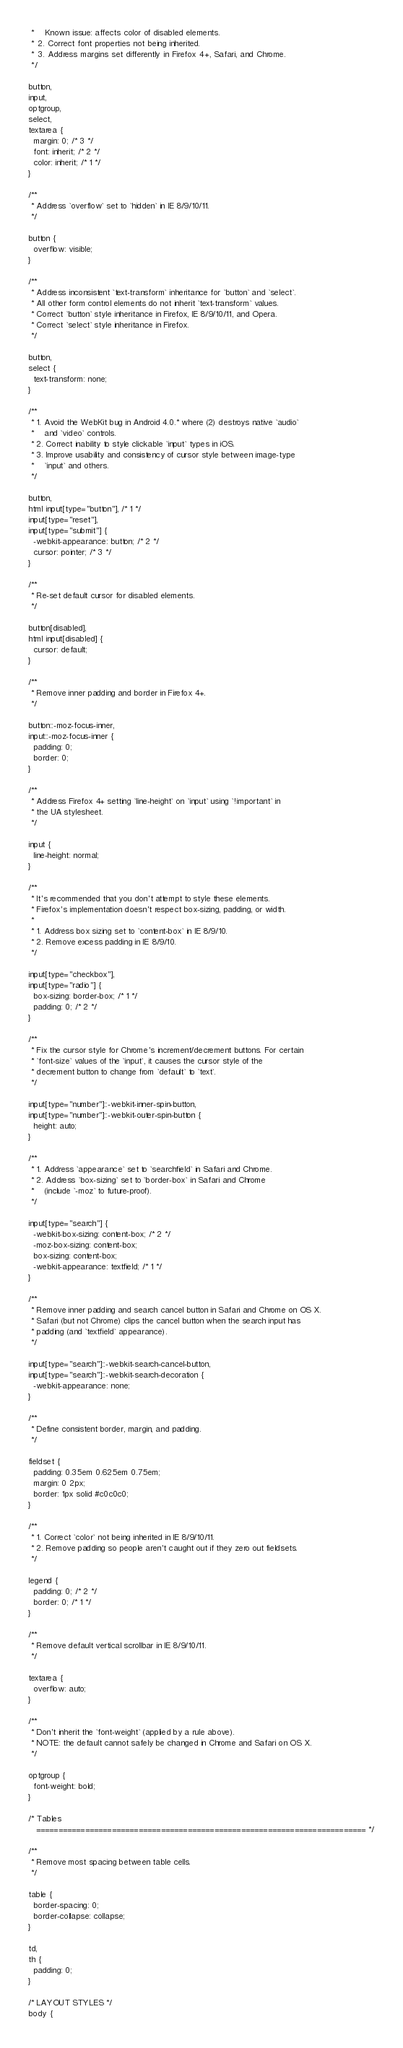Convert code to text. <code><loc_0><loc_0><loc_500><loc_500><_CSS_> *    Known issue: affects color of disabled elements.
 * 2. Correct font properties not being inherited.
 * 3. Address margins set differently in Firefox 4+, Safari, and Chrome.
 */

button,
input,
optgroup,
select,
textarea {
  margin: 0; /* 3 */
  font: inherit; /* 2 */
  color: inherit; /* 1 */
}

/**
 * Address `overflow` set to `hidden` in IE 8/9/10/11.
 */

button {
  overflow: visible;
}

/**
 * Address inconsistent `text-transform` inheritance for `button` and `select`.
 * All other form control elements do not inherit `text-transform` values.
 * Correct `button` style inheritance in Firefox, IE 8/9/10/11, and Opera.
 * Correct `select` style inheritance in Firefox.
 */

button,
select {
  text-transform: none;
}

/**
 * 1. Avoid the WebKit bug in Android 4.0.* where (2) destroys native `audio`
 *    and `video` controls.
 * 2. Correct inability to style clickable `input` types in iOS.
 * 3. Improve usability and consistency of cursor style between image-type
 *    `input` and others.
 */

button,
html input[type="button"], /* 1 */
input[type="reset"],
input[type="submit"] {
  -webkit-appearance: button; /* 2 */
  cursor: pointer; /* 3 */
}

/**
 * Re-set default cursor for disabled elements.
 */

button[disabled],
html input[disabled] {
  cursor: default;
}

/**
 * Remove inner padding and border in Firefox 4+.
 */

button::-moz-focus-inner,
input::-moz-focus-inner {
  padding: 0;
  border: 0;
}

/**
 * Address Firefox 4+ setting `line-height` on `input` using `!important` in
 * the UA stylesheet.
 */

input {
  line-height: normal;
}

/**
 * It's recommended that you don't attempt to style these elements.
 * Firefox's implementation doesn't respect box-sizing, padding, or width.
 *
 * 1. Address box sizing set to `content-box` in IE 8/9/10.
 * 2. Remove excess padding in IE 8/9/10.
 */

input[type="checkbox"],
input[type="radio"] {
  box-sizing: border-box; /* 1 */
  padding: 0; /* 2 */
}

/**
 * Fix the cursor style for Chrome's increment/decrement buttons. For certain
 * `font-size` values of the `input`, it causes the cursor style of the
 * decrement button to change from `default` to `text`.
 */

input[type="number"]::-webkit-inner-spin-button,
input[type="number"]::-webkit-outer-spin-button {
  height: auto;
}

/**
 * 1. Address `appearance` set to `searchfield` in Safari and Chrome.
 * 2. Address `box-sizing` set to `border-box` in Safari and Chrome
 *    (include `-moz` to future-proof).
 */

input[type="search"] {
  -webkit-box-sizing: content-box; /* 2 */
  -moz-box-sizing: content-box;
  box-sizing: content-box;
  -webkit-appearance: textfield; /* 1 */
}

/**
 * Remove inner padding and search cancel button in Safari and Chrome on OS X.
 * Safari (but not Chrome) clips the cancel button when the search input has
 * padding (and `textfield` appearance).
 */

input[type="search"]::-webkit-search-cancel-button,
input[type="search"]::-webkit-search-decoration {
  -webkit-appearance: none;
}

/**
 * Define consistent border, margin, and padding.
 */

fieldset {
  padding: 0.35em 0.625em 0.75em;
  margin: 0 2px;
  border: 1px solid #c0c0c0;
}

/**
 * 1. Correct `color` not being inherited in IE 8/9/10/11.
 * 2. Remove padding so people aren't caught out if they zero out fieldsets.
 */

legend {
  padding: 0; /* 2 */
  border: 0; /* 1 */
}

/**
 * Remove default vertical scrollbar in IE 8/9/10/11.
 */

textarea {
  overflow: auto;
}

/**
 * Don't inherit the `font-weight` (applied by a rule above).
 * NOTE: the default cannot safely be changed in Chrome and Safari on OS X.
 */

optgroup {
  font-weight: bold;
}

/* Tables
   ========================================================================== */

/**
 * Remove most spacing between table cells.
 */

table {
  border-spacing: 0;
  border-collapse: collapse;
}

td,
th {
  padding: 0;
}

/* LAYOUT STYLES */
body {</code> 